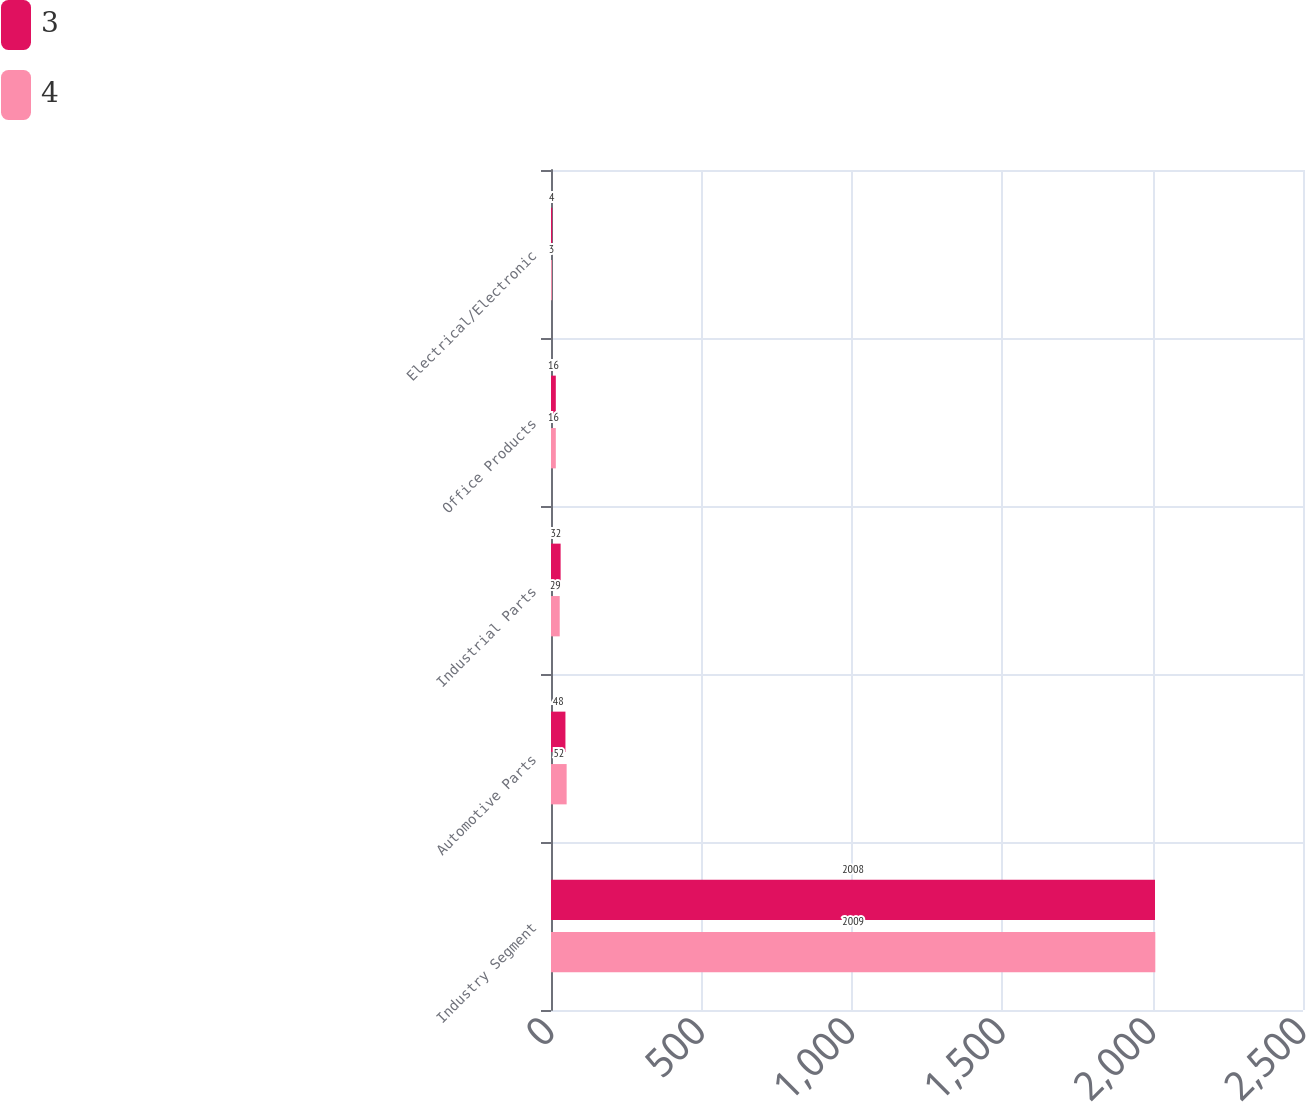Convert chart to OTSL. <chart><loc_0><loc_0><loc_500><loc_500><stacked_bar_chart><ecel><fcel>Industry Segment<fcel>Automotive Parts<fcel>Industrial Parts<fcel>Office Products<fcel>Electrical/Electronic<nl><fcel>3<fcel>2008<fcel>48<fcel>32<fcel>16<fcel>4<nl><fcel>4<fcel>2009<fcel>52<fcel>29<fcel>16<fcel>3<nl></chart> 